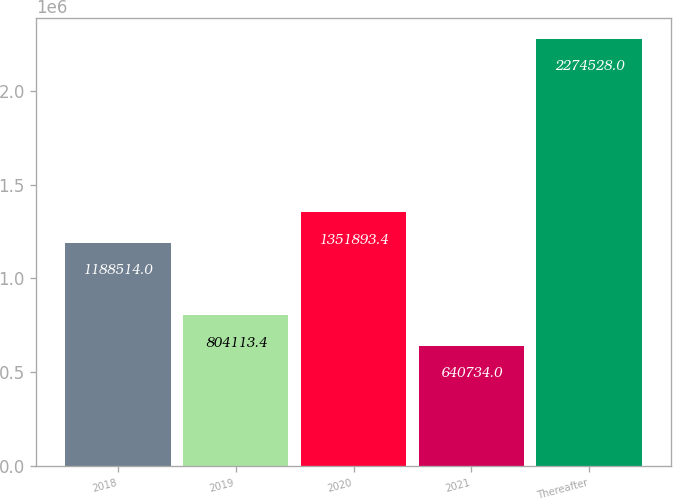<chart> <loc_0><loc_0><loc_500><loc_500><bar_chart><fcel>2018<fcel>2019<fcel>2020<fcel>2021<fcel>Thereafter<nl><fcel>1.18851e+06<fcel>804113<fcel>1.35189e+06<fcel>640734<fcel>2.27453e+06<nl></chart> 